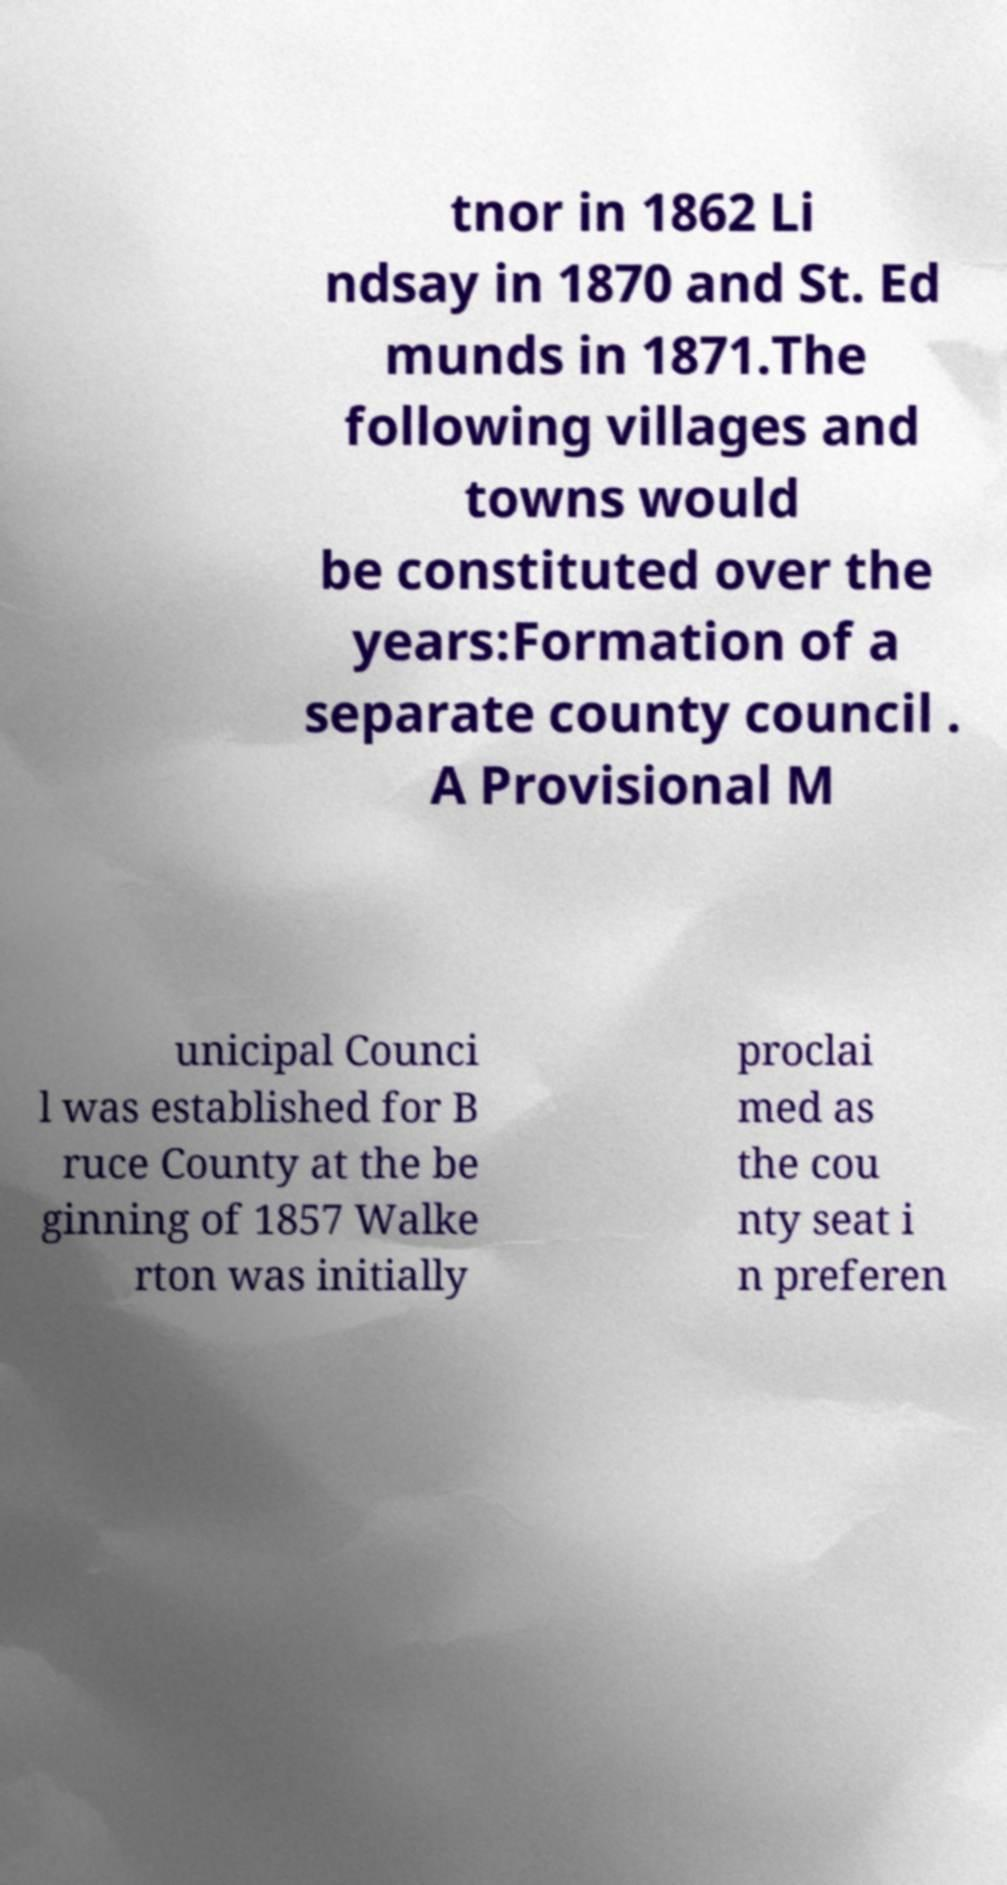There's text embedded in this image that I need extracted. Can you transcribe it verbatim? tnor in 1862 Li ndsay in 1870 and St. Ed munds in 1871.The following villages and towns would be constituted over the years:Formation of a separate county council . A Provisional M unicipal Counci l was established for B ruce County at the be ginning of 1857 Walke rton was initially proclai med as the cou nty seat i n preferen 